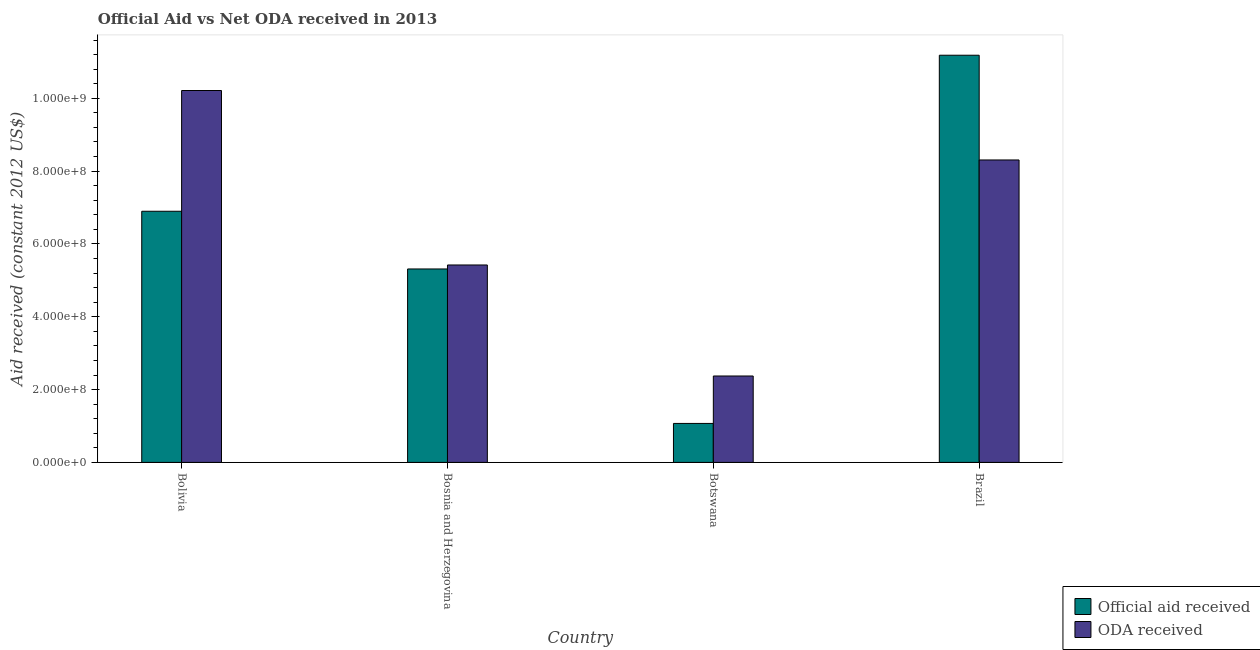How many groups of bars are there?
Give a very brief answer. 4. Are the number of bars on each tick of the X-axis equal?
Offer a very short reply. Yes. How many bars are there on the 2nd tick from the left?
Offer a terse response. 2. What is the label of the 2nd group of bars from the left?
Provide a short and direct response. Bosnia and Herzegovina. In how many cases, is the number of bars for a given country not equal to the number of legend labels?
Your answer should be compact. 0. What is the oda received in Bosnia and Herzegovina?
Provide a short and direct response. 5.42e+08. Across all countries, what is the maximum oda received?
Your answer should be very brief. 1.02e+09. Across all countries, what is the minimum oda received?
Keep it short and to the point. 2.37e+08. In which country was the official aid received minimum?
Ensure brevity in your answer.  Botswana. What is the total official aid received in the graph?
Keep it short and to the point. 2.45e+09. What is the difference between the official aid received in Bolivia and that in Brazil?
Ensure brevity in your answer.  -4.29e+08. What is the difference between the official aid received in Bolivia and the oda received in Brazil?
Keep it short and to the point. -1.41e+08. What is the average oda received per country?
Your response must be concise. 6.58e+08. What is the difference between the oda received and official aid received in Brazil?
Offer a very short reply. -2.88e+08. In how many countries, is the oda received greater than 1040000000 US$?
Your answer should be very brief. 0. What is the ratio of the official aid received in Bolivia to that in Bosnia and Herzegovina?
Provide a succinct answer. 1.3. Is the oda received in Bolivia less than that in Brazil?
Provide a short and direct response. No. Is the difference between the official aid received in Bolivia and Bosnia and Herzegovina greater than the difference between the oda received in Bolivia and Bosnia and Herzegovina?
Give a very brief answer. No. What is the difference between the highest and the second highest oda received?
Provide a succinct answer. 1.91e+08. What is the difference between the highest and the lowest official aid received?
Offer a terse response. 1.01e+09. In how many countries, is the official aid received greater than the average official aid received taken over all countries?
Provide a short and direct response. 2. Is the sum of the oda received in Bolivia and Bosnia and Herzegovina greater than the maximum official aid received across all countries?
Provide a succinct answer. Yes. What does the 2nd bar from the left in Bolivia represents?
Your answer should be very brief. ODA received. What does the 1st bar from the right in Bolivia represents?
Make the answer very short. ODA received. How many bars are there?
Offer a terse response. 8. Are all the bars in the graph horizontal?
Ensure brevity in your answer.  No. What is the difference between two consecutive major ticks on the Y-axis?
Ensure brevity in your answer.  2.00e+08. Are the values on the major ticks of Y-axis written in scientific E-notation?
Offer a very short reply. Yes. Does the graph contain any zero values?
Ensure brevity in your answer.  No. Where does the legend appear in the graph?
Keep it short and to the point. Bottom right. How many legend labels are there?
Your answer should be very brief. 2. How are the legend labels stacked?
Keep it short and to the point. Vertical. What is the title of the graph?
Your response must be concise. Official Aid vs Net ODA received in 2013 . Does "Goods and services" appear as one of the legend labels in the graph?
Your answer should be compact. No. What is the label or title of the Y-axis?
Ensure brevity in your answer.  Aid received (constant 2012 US$). What is the Aid received (constant 2012 US$) in Official aid received in Bolivia?
Provide a succinct answer. 6.90e+08. What is the Aid received (constant 2012 US$) in ODA received in Bolivia?
Offer a very short reply. 1.02e+09. What is the Aid received (constant 2012 US$) in Official aid received in Bosnia and Herzegovina?
Your answer should be compact. 5.31e+08. What is the Aid received (constant 2012 US$) of ODA received in Bosnia and Herzegovina?
Keep it short and to the point. 5.42e+08. What is the Aid received (constant 2012 US$) of Official aid received in Botswana?
Make the answer very short. 1.07e+08. What is the Aid received (constant 2012 US$) of ODA received in Botswana?
Keep it short and to the point. 2.37e+08. What is the Aid received (constant 2012 US$) of Official aid received in Brazil?
Your answer should be compact. 1.12e+09. What is the Aid received (constant 2012 US$) in ODA received in Brazil?
Your answer should be compact. 8.31e+08. Across all countries, what is the maximum Aid received (constant 2012 US$) in Official aid received?
Provide a short and direct response. 1.12e+09. Across all countries, what is the maximum Aid received (constant 2012 US$) in ODA received?
Keep it short and to the point. 1.02e+09. Across all countries, what is the minimum Aid received (constant 2012 US$) of Official aid received?
Your answer should be compact. 1.07e+08. Across all countries, what is the minimum Aid received (constant 2012 US$) of ODA received?
Your answer should be very brief. 2.37e+08. What is the total Aid received (constant 2012 US$) of Official aid received in the graph?
Offer a very short reply. 2.45e+09. What is the total Aid received (constant 2012 US$) in ODA received in the graph?
Ensure brevity in your answer.  2.63e+09. What is the difference between the Aid received (constant 2012 US$) in Official aid received in Bolivia and that in Bosnia and Herzegovina?
Your answer should be very brief. 1.58e+08. What is the difference between the Aid received (constant 2012 US$) in ODA received in Bolivia and that in Bosnia and Herzegovina?
Offer a very short reply. 4.79e+08. What is the difference between the Aid received (constant 2012 US$) of Official aid received in Bolivia and that in Botswana?
Your answer should be very brief. 5.83e+08. What is the difference between the Aid received (constant 2012 US$) of ODA received in Bolivia and that in Botswana?
Keep it short and to the point. 7.84e+08. What is the difference between the Aid received (constant 2012 US$) of Official aid received in Bolivia and that in Brazil?
Make the answer very short. -4.29e+08. What is the difference between the Aid received (constant 2012 US$) of ODA received in Bolivia and that in Brazil?
Ensure brevity in your answer.  1.91e+08. What is the difference between the Aid received (constant 2012 US$) in Official aid received in Bosnia and Herzegovina and that in Botswana?
Make the answer very short. 4.24e+08. What is the difference between the Aid received (constant 2012 US$) of ODA received in Bosnia and Herzegovina and that in Botswana?
Offer a very short reply. 3.05e+08. What is the difference between the Aid received (constant 2012 US$) of Official aid received in Bosnia and Herzegovina and that in Brazil?
Provide a short and direct response. -5.87e+08. What is the difference between the Aid received (constant 2012 US$) of ODA received in Bosnia and Herzegovina and that in Brazil?
Ensure brevity in your answer.  -2.88e+08. What is the difference between the Aid received (constant 2012 US$) in Official aid received in Botswana and that in Brazil?
Offer a very short reply. -1.01e+09. What is the difference between the Aid received (constant 2012 US$) in ODA received in Botswana and that in Brazil?
Offer a terse response. -5.93e+08. What is the difference between the Aid received (constant 2012 US$) of Official aid received in Bolivia and the Aid received (constant 2012 US$) of ODA received in Bosnia and Herzegovina?
Provide a short and direct response. 1.48e+08. What is the difference between the Aid received (constant 2012 US$) in Official aid received in Bolivia and the Aid received (constant 2012 US$) in ODA received in Botswana?
Offer a terse response. 4.52e+08. What is the difference between the Aid received (constant 2012 US$) in Official aid received in Bolivia and the Aid received (constant 2012 US$) in ODA received in Brazil?
Your answer should be compact. -1.41e+08. What is the difference between the Aid received (constant 2012 US$) of Official aid received in Bosnia and Herzegovina and the Aid received (constant 2012 US$) of ODA received in Botswana?
Offer a terse response. 2.94e+08. What is the difference between the Aid received (constant 2012 US$) of Official aid received in Bosnia and Herzegovina and the Aid received (constant 2012 US$) of ODA received in Brazil?
Your answer should be compact. -2.99e+08. What is the difference between the Aid received (constant 2012 US$) of Official aid received in Botswana and the Aid received (constant 2012 US$) of ODA received in Brazil?
Provide a short and direct response. -7.24e+08. What is the average Aid received (constant 2012 US$) in Official aid received per country?
Make the answer very short. 6.12e+08. What is the average Aid received (constant 2012 US$) of ODA received per country?
Your answer should be very brief. 6.58e+08. What is the difference between the Aid received (constant 2012 US$) of Official aid received and Aid received (constant 2012 US$) of ODA received in Bolivia?
Your answer should be compact. -3.32e+08. What is the difference between the Aid received (constant 2012 US$) of Official aid received and Aid received (constant 2012 US$) of ODA received in Bosnia and Herzegovina?
Ensure brevity in your answer.  -1.09e+07. What is the difference between the Aid received (constant 2012 US$) of Official aid received and Aid received (constant 2012 US$) of ODA received in Botswana?
Give a very brief answer. -1.30e+08. What is the difference between the Aid received (constant 2012 US$) of Official aid received and Aid received (constant 2012 US$) of ODA received in Brazil?
Offer a very short reply. 2.88e+08. What is the ratio of the Aid received (constant 2012 US$) of Official aid received in Bolivia to that in Bosnia and Herzegovina?
Keep it short and to the point. 1.3. What is the ratio of the Aid received (constant 2012 US$) in ODA received in Bolivia to that in Bosnia and Herzegovina?
Make the answer very short. 1.88. What is the ratio of the Aid received (constant 2012 US$) in Official aid received in Bolivia to that in Botswana?
Offer a terse response. 6.44. What is the ratio of the Aid received (constant 2012 US$) of ODA received in Bolivia to that in Botswana?
Provide a short and direct response. 4.3. What is the ratio of the Aid received (constant 2012 US$) of Official aid received in Bolivia to that in Brazil?
Ensure brevity in your answer.  0.62. What is the ratio of the Aid received (constant 2012 US$) in ODA received in Bolivia to that in Brazil?
Provide a short and direct response. 1.23. What is the ratio of the Aid received (constant 2012 US$) in Official aid received in Bosnia and Herzegovina to that in Botswana?
Offer a terse response. 4.96. What is the ratio of the Aid received (constant 2012 US$) in ODA received in Bosnia and Herzegovina to that in Botswana?
Provide a short and direct response. 2.28. What is the ratio of the Aid received (constant 2012 US$) of Official aid received in Bosnia and Herzegovina to that in Brazil?
Keep it short and to the point. 0.48. What is the ratio of the Aid received (constant 2012 US$) of ODA received in Bosnia and Herzegovina to that in Brazil?
Your answer should be compact. 0.65. What is the ratio of the Aid received (constant 2012 US$) of Official aid received in Botswana to that in Brazil?
Offer a very short reply. 0.1. What is the ratio of the Aid received (constant 2012 US$) of ODA received in Botswana to that in Brazil?
Your answer should be very brief. 0.29. What is the difference between the highest and the second highest Aid received (constant 2012 US$) in Official aid received?
Your answer should be compact. 4.29e+08. What is the difference between the highest and the second highest Aid received (constant 2012 US$) of ODA received?
Provide a succinct answer. 1.91e+08. What is the difference between the highest and the lowest Aid received (constant 2012 US$) in Official aid received?
Your answer should be very brief. 1.01e+09. What is the difference between the highest and the lowest Aid received (constant 2012 US$) in ODA received?
Your answer should be very brief. 7.84e+08. 